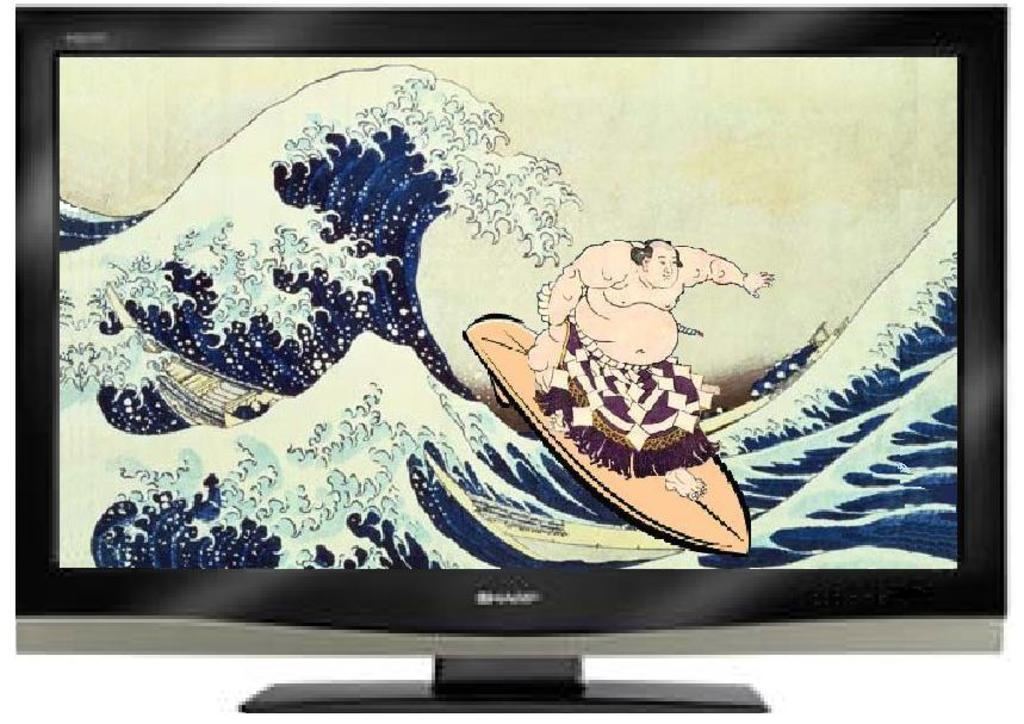What is the main object in the image? There is a monitor in the image. What is displayed on the monitor? The monitor displays a cartoon of a person surfing on a surfboard. Can you describe the scene in the cartoon? The cartoon depicts a person surfing on a surfboard, and there is water in the scene. What type of lettuce is being used to hammer nails in the image? There is no lettuce or hammer present in the image. 